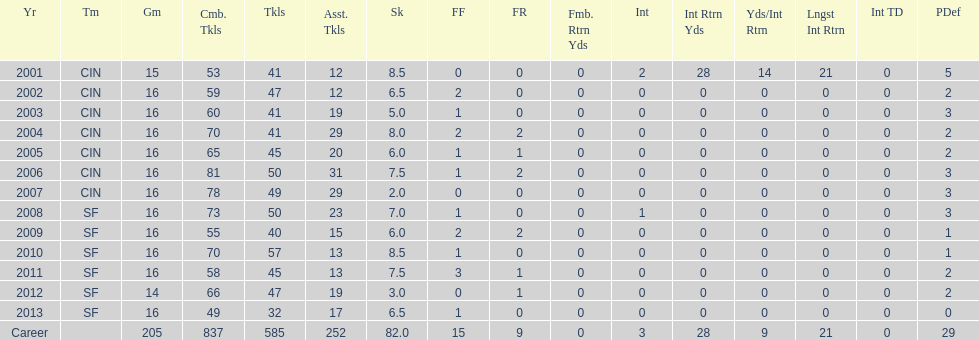How many years did he play where he did not recover a fumble? 7. 